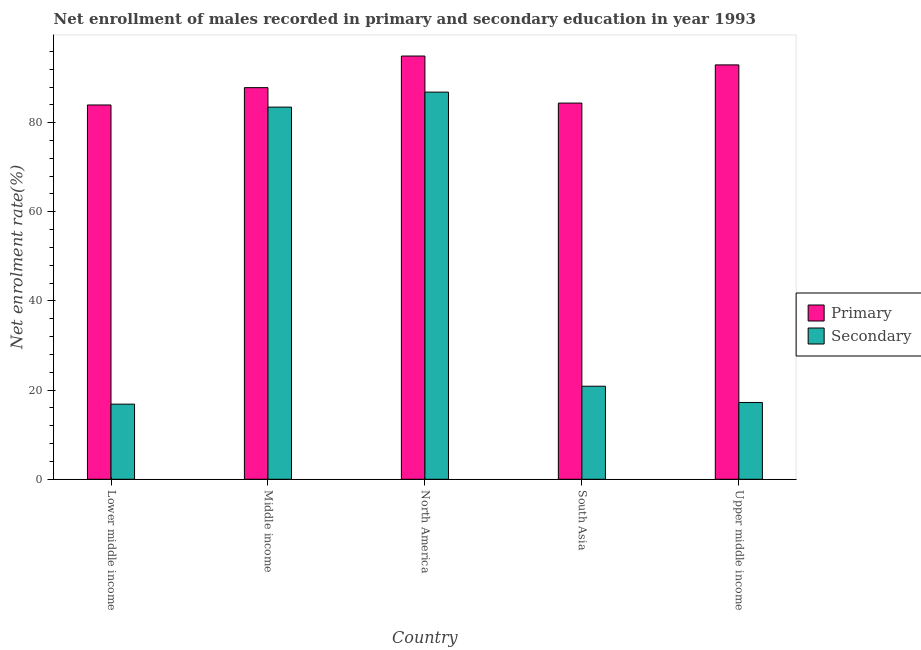How many groups of bars are there?
Provide a succinct answer. 5. Are the number of bars per tick equal to the number of legend labels?
Make the answer very short. Yes. What is the label of the 3rd group of bars from the left?
Your answer should be very brief. North America. In how many cases, is the number of bars for a given country not equal to the number of legend labels?
Give a very brief answer. 0. What is the enrollment rate in secondary education in Upper middle income?
Provide a succinct answer. 17.23. Across all countries, what is the maximum enrollment rate in primary education?
Give a very brief answer. 94.95. Across all countries, what is the minimum enrollment rate in secondary education?
Your answer should be compact. 16.85. In which country was the enrollment rate in primary education minimum?
Keep it short and to the point. Lower middle income. What is the total enrollment rate in secondary education in the graph?
Offer a very short reply. 225.3. What is the difference between the enrollment rate in primary education in Middle income and that in North America?
Your answer should be very brief. -7.09. What is the difference between the enrollment rate in primary education in Upper middle income and the enrollment rate in secondary education in North America?
Your answer should be very brief. 6.11. What is the average enrollment rate in primary education per country?
Offer a terse response. 88.82. What is the difference between the enrollment rate in primary education and enrollment rate in secondary education in North America?
Ensure brevity in your answer.  8.09. What is the ratio of the enrollment rate in secondary education in Middle income to that in North America?
Your answer should be very brief. 0.96. Is the enrollment rate in secondary education in North America less than that in Upper middle income?
Your answer should be very brief. No. What is the difference between the highest and the second highest enrollment rate in primary education?
Keep it short and to the point. 1.99. What is the difference between the highest and the lowest enrollment rate in secondary education?
Give a very brief answer. 70. In how many countries, is the enrollment rate in secondary education greater than the average enrollment rate in secondary education taken over all countries?
Offer a terse response. 2. Is the sum of the enrollment rate in secondary education in South Asia and Upper middle income greater than the maximum enrollment rate in primary education across all countries?
Your response must be concise. No. What does the 1st bar from the left in North America represents?
Ensure brevity in your answer.  Primary. What does the 2nd bar from the right in Lower middle income represents?
Provide a short and direct response. Primary. How many bars are there?
Provide a succinct answer. 10. Are all the bars in the graph horizontal?
Your response must be concise. No. How many countries are there in the graph?
Provide a short and direct response. 5. Are the values on the major ticks of Y-axis written in scientific E-notation?
Make the answer very short. No. Does the graph contain any zero values?
Offer a terse response. No. Does the graph contain grids?
Your answer should be very brief. No. Where does the legend appear in the graph?
Ensure brevity in your answer.  Center right. How many legend labels are there?
Your answer should be compact. 2. What is the title of the graph?
Your response must be concise. Net enrollment of males recorded in primary and secondary education in year 1993. Does "Merchandise exports" appear as one of the legend labels in the graph?
Your answer should be very brief. No. What is the label or title of the X-axis?
Provide a short and direct response. Country. What is the label or title of the Y-axis?
Make the answer very short. Net enrolment rate(%). What is the Net enrolment rate(%) of Primary in Lower middle income?
Your answer should be very brief. 83.97. What is the Net enrolment rate(%) in Secondary in Lower middle income?
Keep it short and to the point. 16.85. What is the Net enrolment rate(%) of Primary in Middle income?
Offer a terse response. 87.86. What is the Net enrolment rate(%) of Secondary in Middle income?
Give a very brief answer. 83.49. What is the Net enrolment rate(%) in Primary in North America?
Your answer should be compact. 94.95. What is the Net enrolment rate(%) in Secondary in North America?
Give a very brief answer. 86.85. What is the Net enrolment rate(%) in Primary in South Asia?
Keep it short and to the point. 84.39. What is the Net enrolment rate(%) of Secondary in South Asia?
Keep it short and to the point. 20.88. What is the Net enrolment rate(%) of Primary in Upper middle income?
Offer a very short reply. 92.96. What is the Net enrolment rate(%) of Secondary in Upper middle income?
Offer a terse response. 17.23. Across all countries, what is the maximum Net enrolment rate(%) in Primary?
Offer a terse response. 94.95. Across all countries, what is the maximum Net enrolment rate(%) in Secondary?
Give a very brief answer. 86.85. Across all countries, what is the minimum Net enrolment rate(%) in Primary?
Make the answer very short. 83.97. Across all countries, what is the minimum Net enrolment rate(%) of Secondary?
Ensure brevity in your answer.  16.85. What is the total Net enrolment rate(%) of Primary in the graph?
Your answer should be very brief. 444.12. What is the total Net enrolment rate(%) of Secondary in the graph?
Your answer should be compact. 225.3. What is the difference between the Net enrolment rate(%) of Primary in Lower middle income and that in Middle income?
Ensure brevity in your answer.  -3.89. What is the difference between the Net enrolment rate(%) in Secondary in Lower middle income and that in Middle income?
Make the answer very short. -66.63. What is the difference between the Net enrolment rate(%) in Primary in Lower middle income and that in North America?
Give a very brief answer. -10.98. What is the difference between the Net enrolment rate(%) in Secondary in Lower middle income and that in North America?
Offer a terse response. -70. What is the difference between the Net enrolment rate(%) in Primary in Lower middle income and that in South Asia?
Keep it short and to the point. -0.42. What is the difference between the Net enrolment rate(%) in Secondary in Lower middle income and that in South Asia?
Make the answer very short. -4.02. What is the difference between the Net enrolment rate(%) in Primary in Lower middle income and that in Upper middle income?
Make the answer very short. -8.99. What is the difference between the Net enrolment rate(%) in Secondary in Lower middle income and that in Upper middle income?
Make the answer very short. -0.37. What is the difference between the Net enrolment rate(%) in Primary in Middle income and that in North America?
Keep it short and to the point. -7.09. What is the difference between the Net enrolment rate(%) in Secondary in Middle income and that in North America?
Ensure brevity in your answer.  -3.37. What is the difference between the Net enrolment rate(%) of Primary in Middle income and that in South Asia?
Provide a succinct answer. 3.46. What is the difference between the Net enrolment rate(%) of Secondary in Middle income and that in South Asia?
Provide a succinct answer. 62.61. What is the difference between the Net enrolment rate(%) in Primary in Middle income and that in Upper middle income?
Provide a short and direct response. -5.1. What is the difference between the Net enrolment rate(%) in Secondary in Middle income and that in Upper middle income?
Provide a short and direct response. 66.26. What is the difference between the Net enrolment rate(%) of Primary in North America and that in South Asia?
Make the answer very short. 10.56. What is the difference between the Net enrolment rate(%) in Secondary in North America and that in South Asia?
Give a very brief answer. 65.98. What is the difference between the Net enrolment rate(%) in Primary in North America and that in Upper middle income?
Your response must be concise. 1.99. What is the difference between the Net enrolment rate(%) of Secondary in North America and that in Upper middle income?
Give a very brief answer. 69.63. What is the difference between the Net enrolment rate(%) in Primary in South Asia and that in Upper middle income?
Give a very brief answer. -8.57. What is the difference between the Net enrolment rate(%) in Secondary in South Asia and that in Upper middle income?
Ensure brevity in your answer.  3.65. What is the difference between the Net enrolment rate(%) of Primary in Lower middle income and the Net enrolment rate(%) of Secondary in Middle income?
Offer a very short reply. 0.48. What is the difference between the Net enrolment rate(%) of Primary in Lower middle income and the Net enrolment rate(%) of Secondary in North America?
Your answer should be compact. -2.89. What is the difference between the Net enrolment rate(%) in Primary in Lower middle income and the Net enrolment rate(%) in Secondary in South Asia?
Provide a succinct answer. 63.09. What is the difference between the Net enrolment rate(%) of Primary in Lower middle income and the Net enrolment rate(%) of Secondary in Upper middle income?
Provide a short and direct response. 66.74. What is the difference between the Net enrolment rate(%) in Primary in Middle income and the Net enrolment rate(%) in Secondary in North America?
Your response must be concise. 1. What is the difference between the Net enrolment rate(%) of Primary in Middle income and the Net enrolment rate(%) of Secondary in South Asia?
Give a very brief answer. 66.98. What is the difference between the Net enrolment rate(%) in Primary in Middle income and the Net enrolment rate(%) in Secondary in Upper middle income?
Your response must be concise. 70.63. What is the difference between the Net enrolment rate(%) in Primary in North America and the Net enrolment rate(%) in Secondary in South Asia?
Give a very brief answer. 74.07. What is the difference between the Net enrolment rate(%) in Primary in North America and the Net enrolment rate(%) in Secondary in Upper middle income?
Offer a terse response. 77.72. What is the difference between the Net enrolment rate(%) of Primary in South Asia and the Net enrolment rate(%) of Secondary in Upper middle income?
Make the answer very short. 67.16. What is the average Net enrolment rate(%) in Primary per country?
Your response must be concise. 88.82. What is the average Net enrolment rate(%) in Secondary per country?
Offer a terse response. 45.06. What is the difference between the Net enrolment rate(%) of Primary and Net enrolment rate(%) of Secondary in Lower middle income?
Your answer should be compact. 67.11. What is the difference between the Net enrolment rate(%) in Primary and Net enrolment rate(%) in Secondary in Middle income?
Keep it short and to the point. 4.37. What is the difference between the Net enrolment rate(%) of Primary and Net enrolment rate(%) of Secondary in North America?
Provide a short and direct response. 8.09. What is the difference between the Net enrolment rate(%) of Primary and Net enrolment rate(%) of Secondary in South Asia?
Offer a very short reply. 63.52. What is the difference between the Net enrolment rate(%) in Primary and Net enrolment rate(%) in Secondary in Upper middle income?
Make the answer very short. 75.73. What is the ratio of the Net enrolment rate(%) in Primary in Lower middle income to that in Middle income?
Your answer should be very brief. 0.96. What is the ratio of the Net enrolment rate(%) in Secondary in Lower middle income to that in Middle income?
Your answer should be very brief. 0.2. What is the ratio of the Net enrolment rate(%) in Primary in Lower middle income to that in North America?
Offer a very short reply. 0.88. What is the ratio of the Net enrolment rate(%) of Secondary in Lower middle income to that in North America?
Give a very brief answer. 0.19. What is the ratio of the Net enrolment rate(%) of Primary in Lower middle income to that in South Asia?
Your answer should be compact. 0.99. What is the ratio of the Net enrolment rate(%) of Secondary in Lower middle income to that in South Asia?
Your answer should be very brief. 0.81. What is the ratio of the Net enrolment rate(%) of Primary in Lower middle income to that in Upper middle income?
Offer a very short reply. 0.9. What is the ratio of the Net enrolment rate(%) in Secondary in Lower middle income to that in Upper middle income?
Make the answer very short. 0.98. What is the ratio of the Net enrolment rate(%) in Primary in Middle income to that in North America?
Offer a very short reply. 0.93. What is the ratio of the Net enrolment rate(%) in Secondary in Middle income to that in North America?
Ensure brevity in your answer.  0.96. What is the ratio of the Net enrolment rate(%) in Primary in Middle income to that in South Asia?
Your answer should be compact. 1.04. What is the ratio of the Net enrolment rate(%) of Secondary in Middle income to that in South Asia?
Keep it short and to the point. 4. What is the ratio of the Net enrolment rate(%) of Primary in Middle income to that in Upper middle income?
Provide a succinct answer. 0.95. What is the ratio of the Net enrolment rate(%) in Secondary in Middle income to that in Upper middle income?
Keep it short and to the point. 4.85. What is the ratio of the Net enrolment rate(%) of Primary in North America to that in South Asia?
Provide a short and direct response. 1.13. What is the ratio of the Net enrolment rate(%) in Secondary in North America to that in South Asia?
Keep it short and to the point. 4.16. What is the ratio of the Net enrolment rate(%) in Primary in North America to that in Upper middle income?
Your answer should be compact. 1.02. What is the ratio of the Net enrolment rate(%) of Secondary in North America to that in Upper middle income?
Provide a succinct answer. 5.04. What is the ratio of the Net enrolment rate(%) of Primary in South Asia to that in Upper middle income?
Offer a terse response. 0.91. What is the ratio of the Net enrolment rate(%) of Secondary in South Asia to that in Upper middle income?
Provide a succinct answer. 1.21. What is the difference between the highest and the second highest Net enrolment rate(%) in Primary?
Offer a very short reply. 1.99. What is the difference between the highest and the second highest Net enrolment rate(%) in Secondary?
Make the answer very short. 3.37. What is the difference between the highest and the lowest Net enrolment rate(%) of Primary?
Provide a short and direct response. 10.98. What is the difference between the highest and the lowest Net enrolment rate(%) of Secondary?
Provide a short and direct response. 70. 